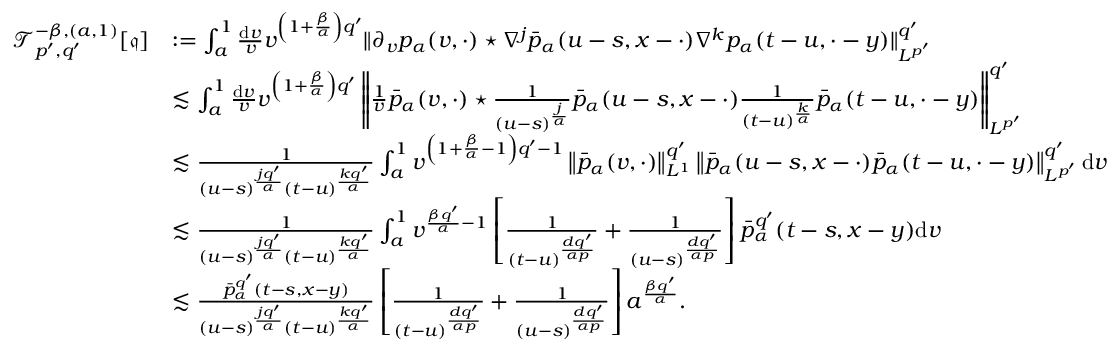<formula> <loc_0><loc_0><loc_500><loc_500>\begin{array} { r l } { \mathcal { T } _ { p ^ { \prime } , q ^ { \prime } } ^ { - \beta , ( a , 1 ) } [ \mathfrak { q } ] } & { \colon = \int _ { a } ^ { 1 } \frac { d v } { v } v ^ { \left ( 1 + \frac { \beta } { \alpha } \right ) q ^ { \prime } } \| \partial _ { v } p _ { \alpha } ( v , \cdot ) ^ { * } \nabla ^ { j } \bar { p } _ { \alpha } ( u - s , x - \cdot ) \nabla ^ { k } p _ { \alpha } ( t - u , \cdot - y ) \| _ { L ^ { p ^ { \prime } } } ^ { q ^ { \prime } } } \\ & { \lesssim \int _ { a } ^ { 1 } \frac { d v } { v } v ^ { \left ( 1 + \frac { \beta } { \alpha } \right ) q ^ { \prime } } \left \| \frac { 1 } { v } \bar { p } _ { \alpha } ( v , \cdot ) ^ { * } \frac { 1 } { ( u - s ) ^ { \frac { j } { \alpha } } } \bar { p } _ { \alpha } ( u - s , x - \cdot ) \frac { 1 } { ( t - u ) ^ { \frac { k } { \alpha } } } \bar { p } _ { \alpha } ( t - u , \cdot - y ) \right \| _ { L ^ { p ^ { \prime } } } ^ { q ^ { \prime } } } \\ & { \lesssim \frac { 1 } { ( u - s ) ^ { \frac { j q ^ { \prime } } { \alpha } } ( t - u ) ^ { \frac { k q ^ { \prime } } { \alpha } } } \int _ { a } ^ { 1 } v ^ { \left ( 1 + \frac { \beta } { \alpha } - 1 \right ) q ^ { \prime } - 1 } \left \| \bar { p } _ { \alpha } ( v , \cdot ) \right \| _ { L ^ { 1 } } ^ { q ^ { \prime } } \left \| \bar { p } _ { \alpha } ( u - s , x - \cdot ) \bar { p } _ { \alpha } ( t - u , \cdot - y ) \right \| _ { L ^ { p ^ { \prime } } } ^ { q ^ { \prime } } d v } \\ & { \lesssim \frac { 1 } { ( u - s ) ^ { \frac { j q ^ { \prime } } { \alpha } } ( t - u ) ^ { \frac { k q ^ { \prime } } { \alpha } } } \int _ { a } ^ { 1 } v ^ { \frac { \beta q ^ { \prime } } { \alpha } - 1 } \left [ \frac { 1 } { ( t - u ) ^ { \frac { d q ^ { \prime } } { \alpha p } } } + \frac { 1 } { ( u - s ) ^ { \frac { d q ^ { \prime } } { \alpha p } } } \right ] \bar { p } _ { \alpha } ^ { q ^ { \prime } } ( t - s , x - y ) d v } \\ & { \lesssim \frac { \bar { p } _ { \alpha } ^ { q ^ { \prime } } ( t - s , x - y ) } { ( u - s ) ^ { \frac { j q ^ { \prime } } { \alpha } } ( t - u ) ^ { \frac { k q ^ { \prime } } { \alpha } } } \left [ \frac { 1 } { ( t - u ) ^ { \frac { d q ^ { \prime } } { \alpha p } } } + \frac { 1 } { ( u - s ) ^ { \frac { d q ^ { \prime } } { \alpha p } } } \right ] a ^ { \frac { \beta q ^ { \prime } } { \alpha } } . } \end{array}</formula> 